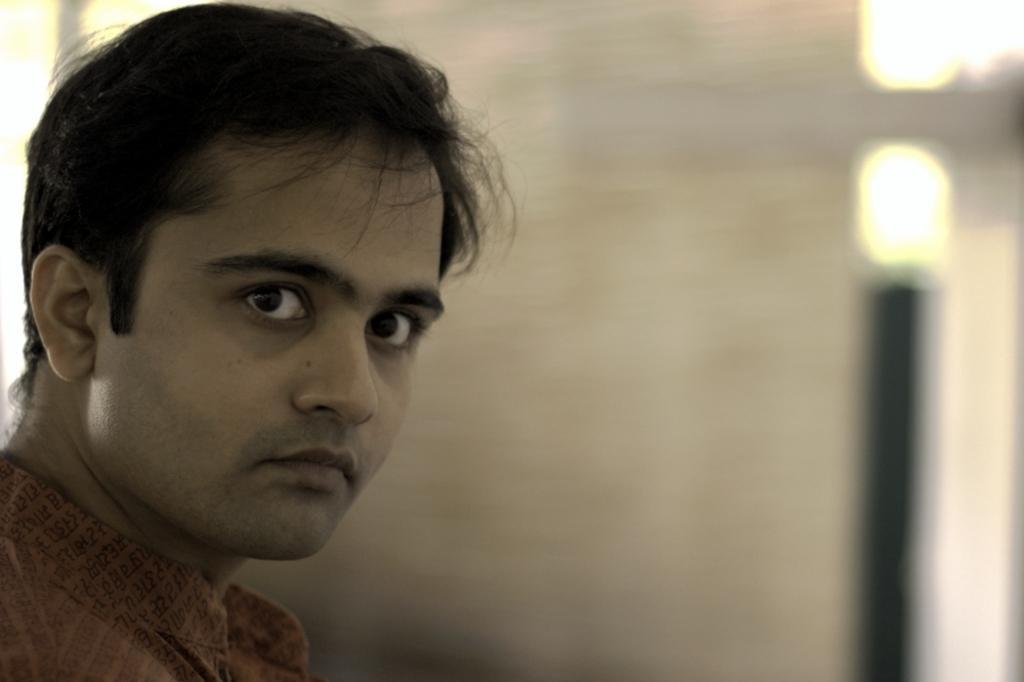Could you give a brief overview of what you see in this image? In this image there is a man. On the right side top corner there are lights. 